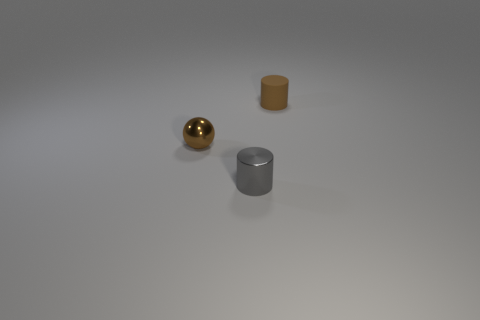Add 3 tiny blue spheres. How many objects exist? 6 Subtract all spheres. How many objects are left? 2 Add 2 tiny metal cylinders. How many tiny metal cylinders are left? 3 Add 3 large gray balls. How many large gray balls exist? 3 Subtract 0 cyan cubes. How many objects are left? 3 Subtract all red spheres. Subtract all gray blocks. How many spheres are left? 1 Subtract all small gray objects. Subtract all tiny purple cylinders. How many objects are left? 2 